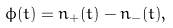Convert formula to latex. <formula><loc_0><loc_0><loc_500><loc_500>\phi ( t ) = n _ { + } ( t ) - n _ { - } ( t ) ,</formula> 